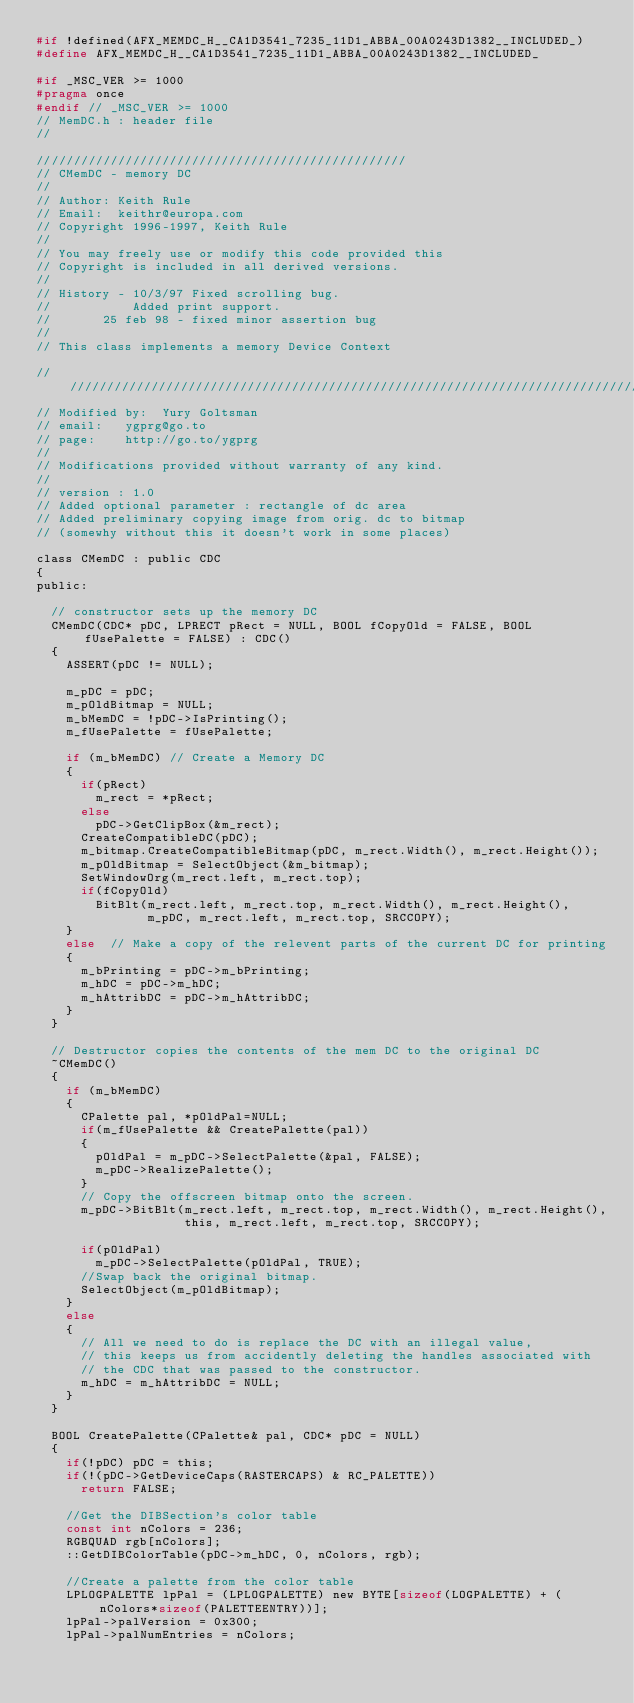<code> <loc_0><loc_0><loc_500><loc_500><_C_>#if !defined(AFX_MEMDC_H__CA1D3541_7235_11D1_ABBA_00A0243D1382__INCLUDED_)
#define AFX_MEMDC_H__CA1D3541_7235_11D1_ABBA_00A0243D1382__INCLUDED_

#if _MSC_VER >= 1000
#pragma once
#endif // _MSC_VER >= 1000
// MemDC.h : header file
//

//////////////////////////////////////////////////
// CMemDC - memory DC
//
// Author: Keith Rule
// Email:  keithr@europa.com
// Copyright 1996-1997, Keith Rule
//
// You may freely use or modify this code provided this
// Copyright is included in all derived versions.
//
// History - 10/3/97 Fixed scrolling bug.
//					 Added print support.
//			 25 feb 98 - fixed minor assertion bug
//
// This class implements a memory Device Context

///////////////////////////////////////////////////////////////////////////////
// Modified by:  Yury Goltsman
// email:   ygprg@go.to
// page:    http://go.to/ygprg
//
// Modifications provided without warranty of any kind.
//
// version : 1.0
// Added optional parameter : rectangle of dc area
// Added preliminary copying image from orig. dc to bitmap
// (somewhy without this it doesn't work in some places)

class CMemDC : public CDC
{
public:

	// constructor sets up the memory DC
	CMemDC(CDC* pDC, LPRECT pRect = NULL, BOOL fCopyOld = FALSE, BOOL fUsePalette = FALSE) : CDC()
	{
		ASSERT(pDC != NULL);

		m_pDC = pDC;
		m_pOldBitmap = NULL;
		m_bMemDC = !pDC->IsPrinting();
		m_fUsePalette = fUsePalette;

		if (m_bMemDC) // Create a Memory DC
		{
			if(pRect)
				m_rect = *pRect;
			else
				pDC->GetClipBox(&m_rect);
			CreateCompatibleDC(pDC);
			m_bitmap.CreateCompatibleBitmap(pDC, m_rect.Width(), m_rect.Height());
			m_pOldBitmap = SelectObject(&m_bitmap);
			SetWindowOrg(m_rect.left, m_rect.top);
			if(fCopyOld)
				BitBlt(m_rect.left, m_rect.top, m_rect.Width(), m_rect.Height(),
				       m_pDC, m_rect.left, m_rect.top, SRCCOPY);
		}
		else  // Make a copy of the relevent parts of the current DC for printing
		{
			m_bPrinting = pDC->m_bPrinting;
			m_hDC = pDC->m_hDC;
			m_hAttribDC = pDC->m_hAttribDC;
		}
	}
	
	// Destructor copies the contents of the mem DC to the original DC
	~CMemDC()
	{
		if (m_bMemDC) 
		{	 
			CPalette pal, *pOldPal=NULL;
			if(m_fUsePalette && CreatePalette(pal))
			{
				pOldPal = m_pDC->SelectPalette(&pal, FALSE);
				m_pDC->RealizePalette();
			}
			// Copy the offscreen bitmap onto the screen.
			m_pDC->BitBlt(m_rect.left, m_rect.top, m_rect.Width(), m_rect.Height(),
			              this, m_rect.left, m_rect.top, SRCCOPY);

			if(pOldPal)
				m_pDC->SelectPalette(pOldPal, TRUE);
			//Swap back the original bitmap.
			SelectObject(m_pOldBitmap);
		} 
		else 
		{
			// All we need to do is replace the DC with an illegal value,
			// this keeps us from accidently deleting the handles associated with
			// the CDC that was passed to the constructor.
			m_hDC = m_hAttribDC = NULL;
		}
	}

	BOOL CreatePalette(CPalette& pal, CDC* pDC = NULL)
	{
		if(!pDC) pDC = this;
		if(!(pDC->GetDeviceCaps(RASTERCAPS) & RC_PALETTE))
			return FALSE;

		//Get the DIBSection's color table
		const int nColors = 236;
		RGBQUAD rgb[nColors];
		::GetDIBColorTable(pDC->m_hDC, 0, nColors, rgb);

		//Create a palette from the color table
		LPLOGPALETTE lpPal = (LPLOGPALETTE) new BYTE[sizeof(LOGPALETTE) + (nColors*sizeof(PALETTEENTRY))];
		lpPal->palVersion = 0x300;       
		lpPal->palNumEntries = nColors;
</code> 